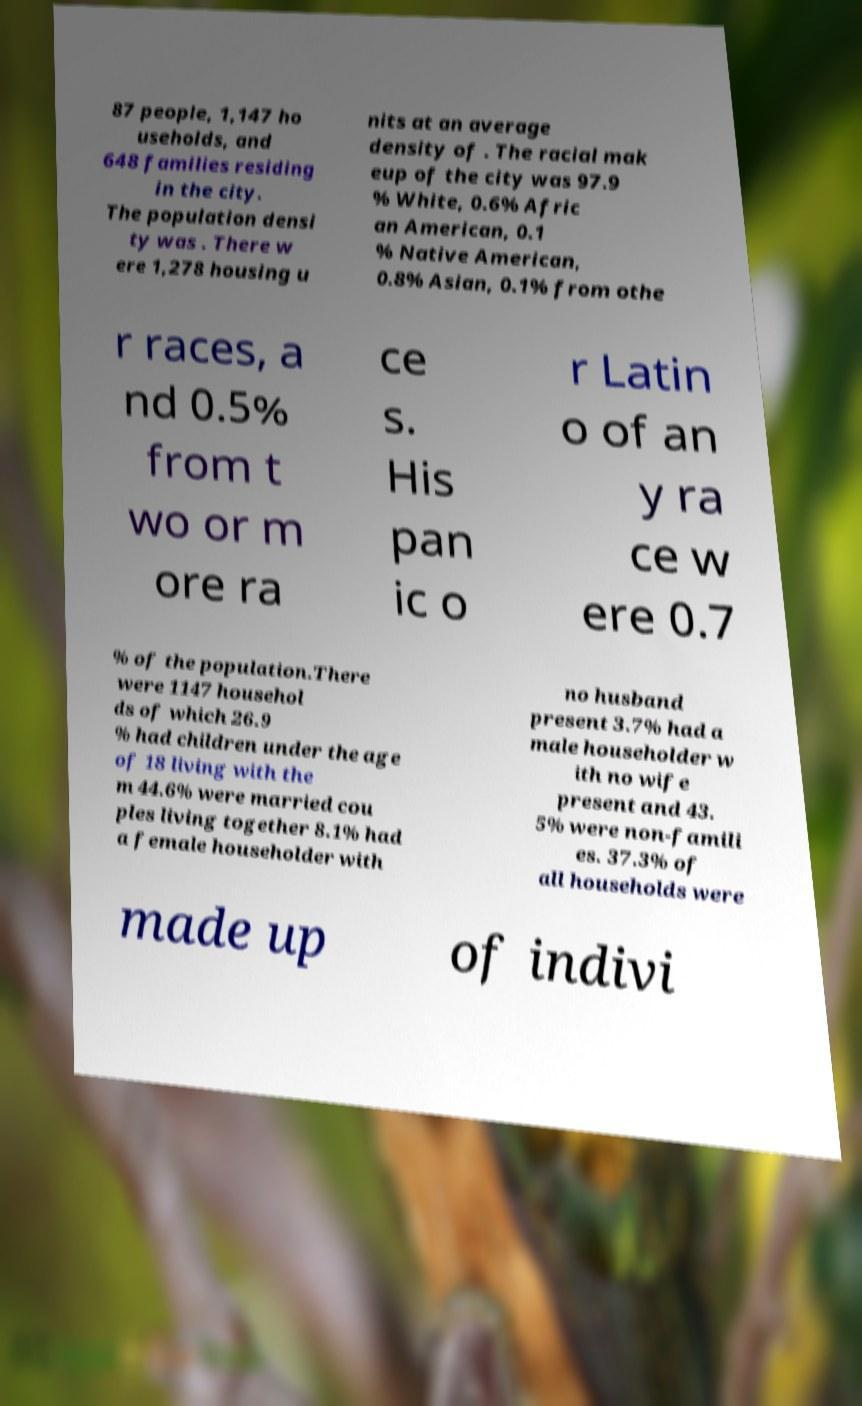There's text embedded in this image that I need extracted. Can you transcribe it verbatim? 87 people, 1,147 ho useholds, and 648 families residing in the city. The population densi ty was . There w ere 1,278 housing u nits at an average density of . The racial mak eup of the city was 97.9 % White, 0.6% Afric an American, 0.1 % Native American, 0.8% Asian, 0.1% from othe r races, a nd 0.5% from t wo or m ore ra ce s. His pan ic o r Latin o of an y ra ce w ere 0.7 % of the population.There were 1147 househol ds of which 26.9 % had children under the age of 18 living with the m 44.6% were married cou ples living together 8.1% had a female householder with no husband present 3.7% had a male householder w ith no wife present and 43. 5% were non-famili es. 37.3% of all households were made up of indivi 